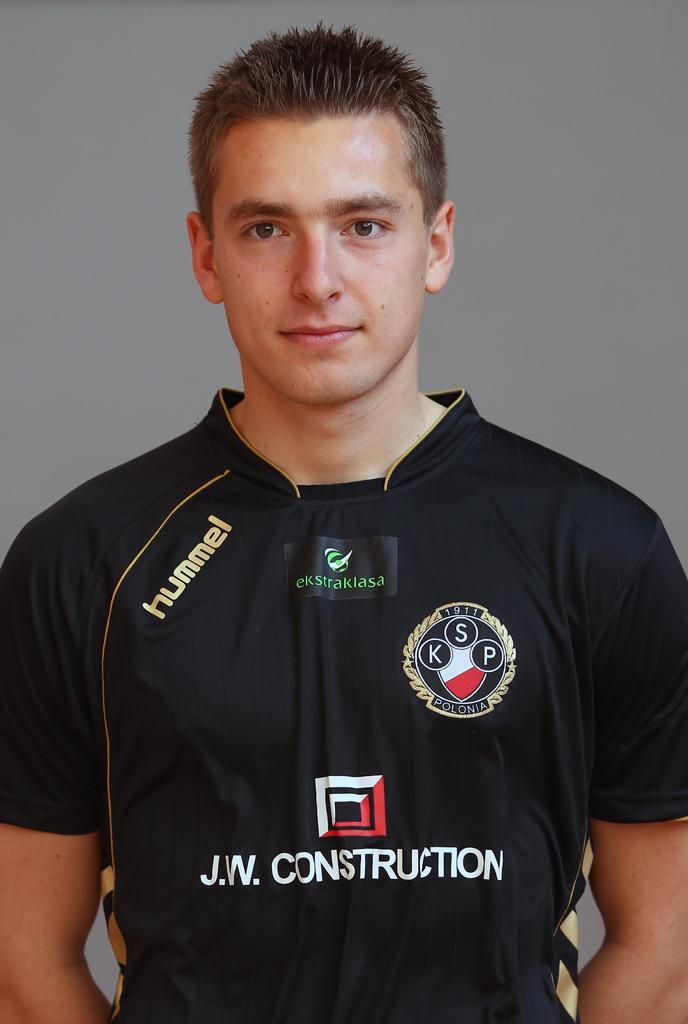Is hummel a sponsor?
Provide a short and direct response. Yes. What is the name of the construction sponsor?
Offer a very short reply. J.w. construction. 